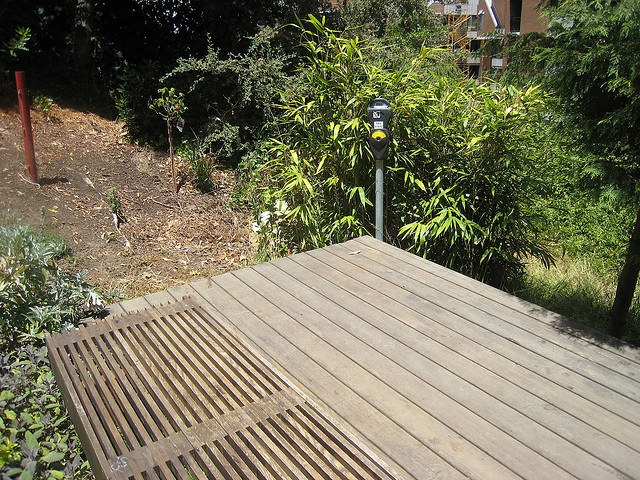Describe the objects in this image and their specific colors. I can see bench in black, tan, darkgray, and gray tones and parking meter in black, gray, and lightgray tones in this image. 